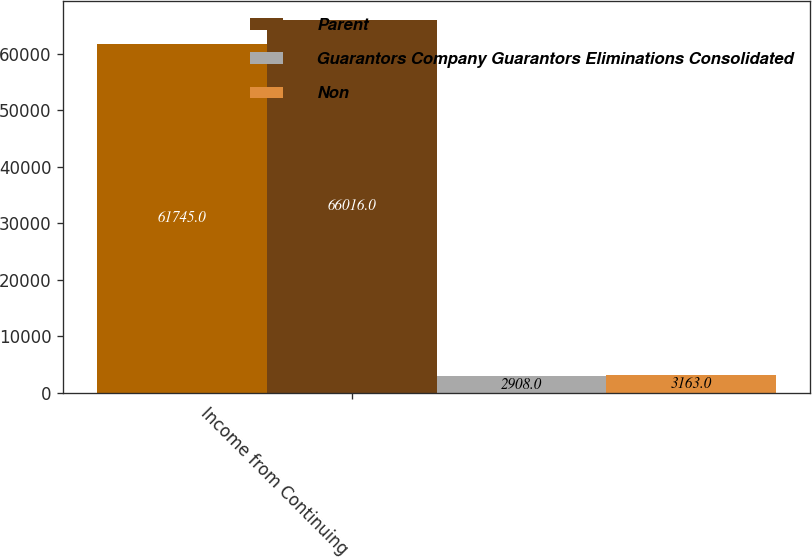Convert chart to OTSL. <chart><loc_0><loc_0><loc_500><loc_500><stacked_bar_chart><ecel><fcel>Income from Continuing<nl><fcel>nan<fcel>61745<nl><fcel>Parent<fcel>66016<nl><fcel>Guarantors Company Guarantors Eliminations Consolidated<fcel>2908<nl><fcel>Non<fcel>3163<nl></chart> 